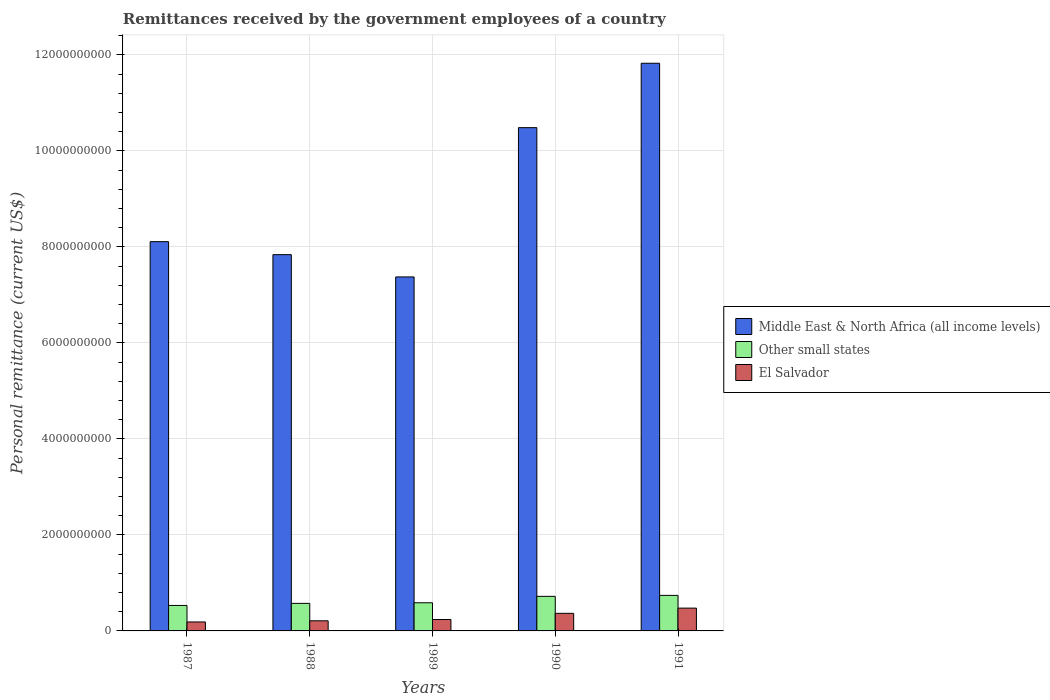How many different coloured bars are there?
Offer a terse response. 3. How many groups of bars are there?
Give a very brief answer. 5. How many bars are there on the 1st tick from the left?
Provide a succinct answer. 3. In how many cases, is the number of bars for a given year not equal to the number of legend labels?
Make the answer very short. 0. What is the remittances received by the government employees in El Salvador in 1988?
Make the answer very short. 2.11e+08. Across all years, what is the maximum remittances received by the government employees in Middle East & North Africa (all income levels)?
Your answer should be compact. 1.18e+1. Across all years, what is the minimum remittances received by the government employees in Other small states?
Ensure brevity in your answer.  5.31e+08. What is the total remittances received by the government employees in Other small states in the graph?
Ensure brevity in your answer.  3.15e+09. What is the difference between the remittances received by the government employees in El Salvador in 1987 and that in 1991?
Provide a succinct answer. -2.89e+08. What is the difference between the remittances received by the government employees in El Salvador in 1987 and the remittances received by the government employees in Other small states in 1989?
Keep it short and to the point. -4.00e+08. What is the average remittances received by the government employees in Middle East & North Africa (all income levels) per year?
Ensure brevity in your answer.  9.13e+09. In the year 1988, what is the difference between the remittances received by the government employees in Other small states and remittances received by the government employees in Middle East & North Africa (all income levels)?
Offer a terse response. -7.26e+09. In how many years, is the remittances received by the government employees in El Salvador greater than 8800000000 US$?
Provide a short and direct response. 0. What is the ratio of the remittances received by the government employees in Middle East & North Africa (all income levels) in 1987 to that in 1988?
Make the answer very short. 1.03. Is the remittances received by the government employees in El Salvador in 1987 less than that in 1990?
Ensure brevity in your answer.  Yes. What is the difference between the highest and the second highest remittances received by the government employees in Middle East & North Africa (all income levels)?
Make the answer very short. 1.34e+09. What is the difference between the highest and the lowest remittances received by the government employees in Other small states?
Give a very brief answer. 2.10e+08. In how many years, is the remittances received by the government employees in Middle East & North Africa (all income levels) greater than the average remittances received by the government employees in Middle East & North Africa (all income levels) taken over all years?
Give a very brief answer. 2. Is the sum of the remittances received by the government employees in Other small states in 1987 and 1990 greater than the maximum remittances received by the government employees in Middle East & North Africa (all income levels) across all years?
Provide a succinct answer. No. What does the 2nd bar from the left in 1988 represents?
Give a very brief answer. Other small states. What does the 1st bar from the right in 1990 represents?
Your response must be concise. El Salvador. Is it the case that in every year, the sum of the remittances received by the government employees in Middle East & North Africa (all income levels) and remittances received by the government employees in El Salvador is greater than the remittances received by the government employees in Other small states?
Offer a terse response. Yes. Are the values on the major ticks of Y-axis written in scientific E-notation?
Provide a succinct answer. No. Where does the legend appear in the graph?
Your response must be concise. Center right. How many legend labels are there?
Your response must be concise. 3. What is the title of the graph?
Your response must be concise. Remittances received by the government employees of a country. What is the label or title of the Y-axis?
Your answer should be very brief. Personal remittance (current US$). What is the Personal remittance (current US$) of Middle East & North Africa (all income levels) in 1987?
Give a very brief answer. 8.11e+09. What is the Personal remittance (current US$) in Other small states in 1987?
Provide a short and direct response. 5.31e+08. What is the Personal remittance (current US$) in El Salvador in 1987?
Make the answer very short. 1.87e+08. What is the Personal remittance (current US$) in Middle East & North Africa (all income levels) in 1988?
Offer a terse response. 7.84e+09. What is the Personal remittance (current US$) of Other small states in 1988?
Provide a succinct answer. 5.74e+08. What is the Personal remittance (current US$) in El Salvador in 1988?
Offer a very short reply. 2.11e+08. What is the Personal remittance (current US$) of Middle East & North Africa (all income levels) in 1989?
Your answer should be very brief. 7.37e+09. What is the Personal remittance (current US$) of Other small states in 1989?
Make the answer very short. 5.87e+08. What is the Personal remittance (current US$) of El Salvador in 1989?
Ensure brevity in your answer.  2.38e+08. What is the Personal remittance (current US$) in Middle East & North Africa (all income levels) in 1990?
Give a very brief answer. 1.05e+1. What is the Personal remittance (current US$) of Other small states in 1990?
Offer a very short reply. 7.20e+08. What is the Personal remittance (current US$) in El Salvador in 1990?
Offer a terse response. 3.66e+08. What is the Personal remittance (current US$) of Middle East & North Africa (all income levels) in 1991?
Provide a short and direct response. 1.18e+1. What is the Personal remittance (current US$) of Other small states in 1991?
Your answer should be compact. 7.40e+08. What is the Personal remittance (current US$) in El Salvador in 1991?
Provide a short and direct response. 4.75e+08. Across all years, what is the maximum Personal remittance (current US$) in Middle East & North Africa (all income levels)?
Your answer should be compact. 1.18e+1. Across all years, what is the maximum Personal remittance (current US$) of Other small states?
Make the answer very short. 7.40e+08. Across all years, what is the maximum Personal remittance (current US$) of El Salvador?
Your response must be concise. 4.75e+08. Across all years, what is the minimum Personal remittance (current US$) of Middle East & North Africa (all income levels)?
Keep it short and to the point. 7.37e+09. Across all years, what is the minimum Personal remittance (current US$) in Other small states?
Provide a short and direct response. 5.31e+08. Across all years, what is the minimum Personal remittance (current US$) in El Salvador?
Keep it short and to the point. 1.87e+08. What is the total Personal remittance (current US$) of Middle East & North Africa (all income levels) in the graph?
Your response must be concise. 4.56e+1. What is the total Personal remittance (current US$) of Other small states in the graph?
Your response must be concise. 3.15e+09. What is the total Personal remittance (current US$) in El Salvador in the graph?
Your answer should be compact. 1.48e+09. What is the difference between the Personal remittance (current US$) of Middle East & North Africa (all income levels) in 1987 and that in 1988?
Offer a terse response. 2.71e+08. What is the difference between the Personal remittance (current US$) in Other small states in 1987 and that in 1988?
Your response must be concise. -4.31e+07. What is the difference between the Personal remittance (current US$) in El Salvador in 1987 and that in 1988?
Give a very brief answer. -2.41e+07. What is the difference between the Personal remittance (current US$) in Middle East & North Africa (all income levels) in 1987 and that in 1989?
Offer a terse response. 7.35e+08. What is the difference between the Personal remittance (current US$) of Other small states in 1987 and that in 1989?
Your answer should be very brief. -5.60e+07. What is the difference between the Personal remittance (current US$) of El Salvador in 1987 and that in 1989?
Keep it short and to the point. -5.12e+07. What is the difference between the Personal remittance (current US$) of Middle East & North Africa (all income levels) in 1987 and that in 1990?
Provide a succinct answer. -2.38e+09. What is the difference between the Personal remittance (current US$) in Other small states in 1987 and that in 1990?
Provide a short and direct response. -1.89e+08. What is the difference between the Personal remittance (current US$) of El Salvador in 1987 and that in 1990?
Offer a terse response. -1.80e+08. What is the difference between the Personal remittance (current US$) of Middle East & North Africa (all income levels) in 1987 and that in 1991?
Keep it short and to the point. -3.72e+09. What is the difference between the Personal remittance (current US$) in Other small states in 1987 and that in 1991?
Provide a short and direct response. -2.10e+08. What is the difference between the Personal remittance (current US$) of El Salvador in 1987 and that in 1991?
Offer a very short reply. -2.89e+08. What is the difference between the Personal remittance (current US$) of Middle East & North Africa (all income levels) in 1988 and that in 1989?
Your answer should be very brief. 4.64e+08. What is the difference between the Personal remittance (current US$) of Other small states in 1988 and that in 1989?
Your response must be concise. -1.29e+07. What is the difference between the Personal remittance (current US$) in El Salvador in 1988 and that in 1989?
Keep it short and to the point. -2.71e+07. What is the difference between the Personal remittance (current US$) of Middle East & North Africa (all income levels) in 1988 and that in 1990?
Your answer should be very brief. -2.65e+09. What is the difference between the Personal remittance (current US$) in Other small states in 1988 and that in 1990?
Ensure brevity in your answer.  -1.46e+08. What is the difference between the Personal remittance (current US$) in El Salvador in 1988 and that in 1990?
Ensure brevity in your answer.  -1.56e+08. What is the difference between the Personal remittance (current US$) of Middle East & North Africa (all income levels) in 1988 and that in 1991?
Provide a short and direct response. -3.99e+09. What is the difference between the Personal remittance (current US$) in Other small states in 1988 and that in 1991?
Give a very brief answer. -1.67e+08. What is the difference between the Personal remittance (current US$) in El Salvador in 1988 and that in 1991?
Ensure brevity in your answer.  -2.64e+08. What is the difference between the Personal remittance (current US$) of Middle East & North Africa (all income levels) in 1989 and that in 1990?
Keep it short and to the point. -3.11e+09. What is the difference between the Personal remittance (current US$) in Other small states in 1989 and that in 1990?
Ensure brevity in your answer.  -1.33e+08. What is the difference between the Personal remittance (current US$) of El Salvador in 1989 and that in 1990?
Provide a succinct answer. -1.28e+08. What is the difference between the Personal remittance (current US$) of Middle East & North Africa (all income levels) in 1989 and that in 1991?
Your answer should be very brief. -4.45e+09. What is the difference between the Personal remittance (current US$) in Other small states in 1989 and that in 1991?
Provide a short and direct response. -1.54e+08. What is the difference between the Personal remittance (current US$) in El Salvador in 1989 and that in 1991?
Provide a short and direct response. -2.37e+08. What is the difference between the Personal remittance (current US$) in Middle East & North Africa (all income levels) in 1990 and that in 1991?
Provide a succinct answer. -1.34e+09. What is the difference between the Personal remittance (current US$) in Other small states in 1990 and that in 1991?
Keep it short and to the point. -2.03e+07. What is the difference between the Personal remittance (current US$) in El Salvador in 1990 and that in 1991?
Provide a short and direct response. -1.09e+08. What is the difference between the Personal remittance (current US$) of Middle East & North Africa (all income levels) in 1987 and the Personal remittance (current US$) of Other small states in 1988?
Provide a succinct answer. 7.54e+09. What is the difference between the Personal remittance (current US$) of Middle East & North Africa (all income levels) in 1987 and the Personal remittance (current US$) of El Salvador in 1988?
Keep it short and to the point. 7.90e+09. What is the difference between the Personal remittance (current US$) in Other small states in 1987 and the Personal remittance (current US$) in El Salvador in 1988?
Ensure brevity in your answer.  3.20e+08. What is the difference between the Personal remittance (current US$) in Middle East & North Africa (all income levels) in 1987 and the Personal remittance (current US$) in Other small states in 1989?
Your response must be concise. 7.52e+09. What is the difference between the Personal remittance (current US$) of Middle East & North Africa (all income levels) in 1987 and the Personal remittance (current US$) of El Salvador in 1989?
Your answer should be very brief. 7.87e+09. What is the difference between the Personal remittance (current US$) of Other small states in 1987 and the Personal remittance (current US$) of El Salvador in 1989?
Give a very brief answer. 2.93e+08. What is the difference between the Personal remittance (current US$) of Middle East & North Africa (all income levels) in 1987 and the Personal remittance (current US$) of Other small states in 1990?
Your answer should be compact. 7.39e+09. What is the difference between the Personal remittance (current US$) in Middle East & North Africa (all income levels) in 1987 and the Personal remittance (current US$) in El Salvador in 1990?
Your response must be concise. 7.74e+09. What is the difference between the Personal remittance (current US$) in Other small states in 1987 and the Personal remittance (current US$) in El Salvador in 1990?
Provide a short and direct response. 1.65e+08. What is the difference between the Personal remittance (current US$) of Middle East & North Africa (all income levels) in 1987 and the Personal remittance (current US$) of Other small states in 1991?
Offer a terse response. 7.37e+09. What is the difference between the Personal remittance (current US$) of Middle East & North Africa (all income levels) in 1987 and the Personal remittance (current US$) of El Salvador in 1991?
Give a very brief answer. 7.63e+09. What is the difference between the Personal remittance (current US$) in Other small states in 1987 and the Personal remittance (current US$) in El Salvador in 1991?
Your response must be concise. 5.56e+07. What is the difference between the Personal remittance (current US$) in Middle East & North Africa (all income levels) in 1988 and the Personal remittance (current US$) in Other small states in 1989?
Make the answer very short. 7.25e+09. What is the difference between the Personal remittance (current US$) of Middle East & North Africa (all income levels) in 1988 and the Personal remittance (current US$) of El Salvador in 1989?
Provide a short and direct response. 7.60e+09. What is the difference between the Personal remittance (current US$) of Other small states in 1988 and the Personal remittance (current US$) of El Salvador in 1989?
Ensure brevity in your answer.  3.36e+08. What is the difference between the Personal remittance (current US$) in Middle East & North Africa (all income levels) in 1988 and the Personal remittance (current US$) in Other small states in 1990?
Give a very brief answer. 7.12e+09. What is the difference between the Personal remittance (current US$) in Middle East & North Africa (all income levels) in 1988 and the Personal remittance (current US$) in El Salvador in 1990?
Make the answer very short. 7.47e+09. What is the difference between the Personal remittance (current US$) in Other small states in 1988 and the Personal remittance (current US$) in El Salvador in 1990?
Keep it short and to the point. 2.08e+08. What is the difference between the Personal remittance (current US$) in Middle East & North Africa (all income levels) in 1988 and the Personal remittance (current US$) in Other small states in 1991?
Ensure brevity in your answer.  7.10e+09. What is the difference between the Personal remittance (current US$) in Middle East & North Africa (all income levels) in 1988 and the Personal remittance (current US$) in El Salvador in 1991?
Keep it short and to the point. 7.36e+09. What is the difference between the Personal remittance (current US$) of Other small states in 1988 and the Personal remittance (current US$) of El Salvador in 1991?
Your response must be concise. 9.87e+07. What is the difference between the Personal remittance (current US$) of Middle East & North Africa (all income levels) in 1989 and the Personal remittance (current US$) of Other small states in 1990?
Give a very brief answer. 6.65e+09. What is the difference between the Personal remittance (current US$) in Middle East & North Africa (all income levels) in 1989 and the Personal remittance (current US$) in El Salvador in 1990?
Keep it short and to the point. 7.01e+09. What is the difference between the Personal remittance (current US$) in Other small states in 1989 and the Personal remittance (current US$) in El Salvador in 1990?
Offer a terse response. 2.21e+08. What is the difference between the Personal remittance (current US$) of Middle East & North Africa (all income levels) in 1989 and the Personal remittance (current US$) of Other small states in 1991?
Give a very brief answer. 6.63e+09. What is the difference between the Personal remittance (current US$) of Middle East & North Africa (all income levels) in 1989 and the Personal remittance (current US$) of El Salvador in 1991?
Offer a terse response. 6.90e+09. What is the difference between the Personal remittance (current US$) in Other small states in 1989 and the Personal remittance (current US$) in El Salvador in 1991?
Your answer should be very brief. 1.12e+08. What is the difference between the Personal remittance (current US$) in Middle East & North Africa (all income levels) in 1990 and the Personal remittance (current US$) in Other small states in 1991?
Offer a very short reply. 9.74e+09. What is the difference between the Personal remittance (current US$) in Middle East & North Africa (all income levels) in 1990 and the Personal remittance (current US$) in El Salvador in 1991?
Provide a short and direct response. 1.00e+1. What is the difference between the Personal remittance (current US$) of Other small states in 1990 and the Personal remittance (current US$) of El Salvador in 1991?
Your answer should be compact. 2.45e+08. What is the average Personal remittance (current US$) of Middle East & North Africa (all income levels) per year?
Give a very brief answer. 9.13e+09. What is the average Personal remittance (current US$) of Other small states per year?
Keep it short and to the point. 6.30e+08. What is the average Personal remittance (current US$) in El Salvador per year?
Your answer should be very brief. 2.95e+08. In the year 1987, what is the difference between the Personal remittance (current US$) of Middle East & North Africa (all income levels) and Personal remittance (current US$) of Other small states?
Give a very brief answer. 7.58e+09. In the year 1987, what is the difference between the Personal remittance (current US$) in Middle East & North Africa (all income levels) and Personal remittance (current US$) in El Salvador?
Give a very brief answer. 7.92e+09. In the year 1987, what is the difference between the Personal remittance (current US$) of Other small states and Personal remittance (current US$) of El Salvador?
Ensure brevity in your answer.  3.44e+08. In the year 1988, what is the difference between the Personal remittance (current US$) of Middle East & North Africa (all income levels) and Personal remittance (current US$) of Other small states?
Give a very brief answer. 7.26e+09. In the year 1988, what is the difference between the Personal remittance (current US$) in Middle East & North Africa (all income levels) and Personal remittance (current US$) in El Salvador?
Your answer should be very brief. 7.63e+09. In the year 1988, what is the difference between the Personal remittance (current US$) in Other small states and Personal remittance (current US$) in El Salvador?
Make the answer very short. 3.63e+08. In the year 1989, what is the difference between the Personal remittance (current US$) in Middle East & North Africa (all income levels) and Personal remittance (current US$) in Other small states?
Ensure brevity in your answer.  6.79e+09. In the year 1989, what is the difference between the Personal remittance (current US$) of Middle East & North Africa (all income levels) and Personal remittance (current US$) of El Salvador?
Provide a succinct answer. 7.14e+09. In the year 1989, what is the difference between the Personal remittance (current US$) in Other small states and Personal remittance (current US$) in El Salvador?
Offer a terse response. 3.49e+08. In the year 1990, what is the difference between the Personal remittance (current US$) in Middle East & North Africa (all income levels) and Personal remittance (current US$) in Other small states?
Keep it short and to the point. 9.76e+09. In the year 1990, what is the difference between the Personal remittance (current US$) of Middle East & North Africa (all income levels) and Personal remittance (current US$) of El Salvador?
Your response must be concise. 1.01e+1. In the year 1990, what is the difference between the Personal remittance (current US$) of Other small states and Personal remittance (current US$) of El Salvador?
Offer a terse response. 3.54e+08. In the year 1991, what is the difference between the Personal remittance (current US$) in Middle East & North Africa (all income levels) and Personal remittance (current US$) in Other small states?
Offer a terse response. 1.11e+1. In the year 1991, what is the difference between the Personal remittance (current US$) of Middle East & North Africa (all income levels) and Personal remittance (current US$) of El Salvador?
Ensure brevity in your answer.  1.14e+1. In the year 1991, what is the difference between the Personal remittance (current US$) of Other small states and Personal remittance (current US$) of El Salvador?
Your answer should be very brief. 2.65e+08. What is the ratio of the Personal remittance (current US$) of Middle East & North Africa (all income levels) in 1987 to that in 1988?
Offer a terse response. 1.03. What is the ratio of the Personal remittance (current US$) of Other small states in 1987 to that in 1988?
Offer a very short reply. 0.93. What is the ratio of the Personal remittance (current US$) of El Salvador in 1987 to that in 1988?
Ensure brevity in your answer.  0.89. What is the ratio of the Personal remittance (current US$) of Middle East & North Africa (all income levels) in 1987 to that in 1989?
Your answer should be compact. 1.1. What is the ratio of the Personal remittance (current US$) of Other small states in 1987 to that in 1989?
Offer a terse response. 0.9. What is the ratio of the Personal remittance (current US$) in El Salvador in 1987 to that in 1989?
Your answer should be very brief. 0.78. What is the ratio of the Personal remittance (current US$) of Middle East & North Africa (all income levels) in 1987 to that in 1990?
Make the answer very short. 0.77. What is the ratio of the Personal remittance (current US$) of Other small states in 1987 to that in 1990?
Offer a very short reply. 0.74. What is the ratio of the Personal remittance (current US$) in El Salvador in 1987 to that in 1990?
Your answer should be compact. 0.51. What is the ratio of the Personal remittance (current US$) of Middle East & North Africa (all income levels) in 1987 to that in 1991?
Make the answer very short. 0.69. What is the ratio of the Personal remittance (current US$) of Other small states in 1987 to that in 1991?
Make the answer very short. 0.72. What is the ratio of the Personal remittance (current US$) of El Salvador in 1987 to that in 1991?
Ensure brevity in your answer.  0.39. What is the ratio of the Personal remittance (current US$) in Middle East & North Africa (all income levels) in 1988 to that in 1989?
Offer a terse response. 1.06. What is the ratio of the Personal remittance (current US$) in El Salvador in 1988 to that in 1989?
Offer a terse response. 0.89. What is the ratio of the Personal remittance (current US$) in Middle East & North Africa (all income levels) in 1988 to that in 1990?
Your answer should be very brief. 0.75. What is the ratio of the Personal remittance (current US$) in Other small states in 1988 to that in 1990?
Provide a succinct answer. 0.8. What is the ratio of the Personal remittance (current US$) of El Salvador in 1988 to that in 1990?
Ensure brevity in your answer.  0.58. What is the ratio of the Personal remittance (current US$) in Middle East & North Africa (all income levels) in 1988 to that in 1991?
Keep it short and to the point. 0.66. What is the ratio of the Personal remittance (current US$) in Other small states in 1988 to that in 1991?
Provide a succinct answer. 0.78. What is the ratio of the Personal remittance (current US$) in El Salvador in 1988 to that in 1991?
Ensure brevity in your answer.  0.44. What is the ratio of the Personal remittance (current US$) of Middle East & North Africa (all income levels) in 1989 to that in 1990?
Provide a succinct answer. 0.7. What is the ratio of the Personal remittance (current US$) of Other small states in 1989 to that in 1990?
Make the answer very short. 0.81. What is the ratio of the Personal remittance (current US$) of El Salvador in 1989 to that in 1990?
Your answer should be compact. 0.65. What is the ratio of the Personal remittance (current US$) of Middle East & North Africa (all income levels) in 1989 to that in 1991?
Ensure brevity in your answer.  0.62. What is the ratio of the Personal remittance (current US$) of Other small states in 1989 to that in 1991?
Keep it short and to the point. 0.79. What is the ratio of the Personal remittance (current US$) of El Salvador in 1989 to that in 1991?
Your answer should be very brief. 0.5. What is the ratio of the Personal remittance (current US$) of Middle East & North Africa (all income levels) in 1990 to that in 1991?
Provide a short and direct response. 0.89. What is the ratio of the Personal remittance (current US$) in Other small states in 1990 to that in 1991?
Ensure brevity in your answer.  0.97. What is the ratio of the Personal remittance (current US$) in El Salvador in 1990 to that in 1991?
Your answer should be compact. 0.77. What is the difference between the highest and the second highest Personal remittance (current US$) of Middle East & North Africa (all income levels)?
Offer a terse response. 1.34e+09. What is the difference between the highest and the second highest Personal remittance (current US$) of Other small states?
Your answer should be compact. 2.03e+07. What is the difference between the highest and the second highest Personal remittance (current US$) of El Salvador?
Your answer should be very brief. 1.09e+08. What is the difference between the highest and the lowest Personal remittance (current US$) of Middle East & North Africa (all income levels)?
Provide a succinct answer. 4.45e+09. What is the difference between the highest and the lowest Personal remittance (current US$) in Other small states?
Provide a short and direct response. 2.10e+08. What is the difference between the highest and the lowest Personal remittance (current US$) of El Salvador?
Keep it short and to the point. 2.89e+08. 